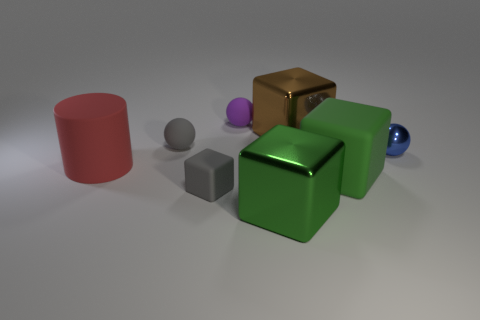What materials are the objects in the image made of? The objects in the image display a variety of materials. The two cubes in front appear to have a matte finish, possibly imitating a rubber texture, while the cube in the back gives off a metallic sheen. The cylinder and spheres also have distinct textures, suggesting they could be made of materials such as plastic or metal with matte and glossy finishes.  Can you describe the lighting and shadows in the scene? The lighting in the image seems to be coming from the upper right, casting diagonal shadows towards the lower left. The softness of the shadows indicates a diffuse light source, and this also helps us appreciate the texture of each object through the highlights and shadows on their surfaces. 